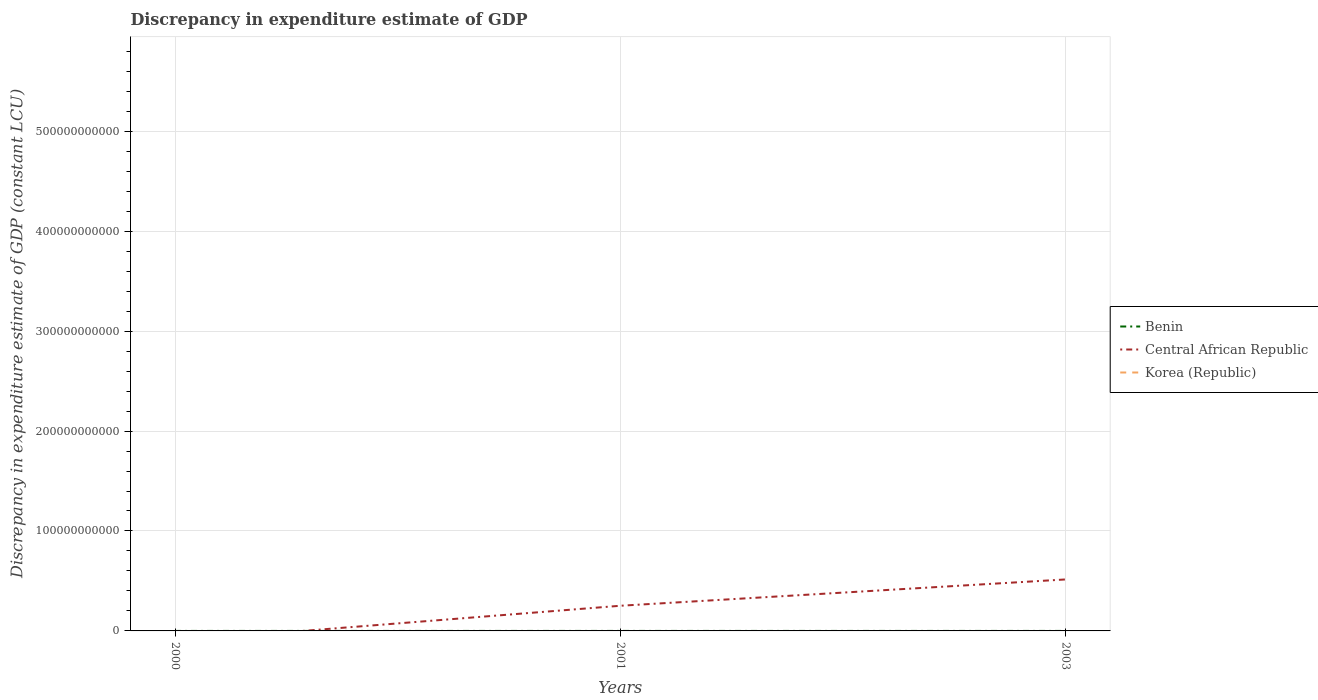Does the line corresponding to Korea (Republic) intersect with the line corresponding to Benin?
Ensure brevity in your answer.  No. Is the number of lines equal to the number of legend labels?
Ensure brevity in your answer.  No. What is the total discrepancy in expenditure estimate of GDP in Central African Republic in the graph?
Offer a very short reply. -2.63e+1. What is the difference between the highest and the lowest discrepancy in expenditure estimate of GDP in Central African Republic?
Your response must be concise. 1. How many lines are there?
Your answer should be compact. 2. What is the difference between two consecutive major ticks on the Y-axis?
Your answer should be compact. 1.00e+11. Are the values on the major ticks of Y-axis written in scientific E-notation?
Your response must be concise. No. Does the graph contain any zero values?
Your answer should be very brief. Yes. Does the graph contain grids?
Your response must be concise. Yes. Where does the legend appear in the graph?
Your answer should be very brief. Center right. How many legend labels are there?
Give a very brief answer. 3. What is the title of the graph?
Offer a very short reply. Discrepancy in expenditure estimate of GDP. Does "Brunei Darussalam" appear as one of the legend labels in the graph?
Ensure brevity in your answer.  No. What is the label or title of the Y-axis?
Provide a succinct answer. Discrepancy in expenditure estimate of GDP (constant LCU). What is the Discrepancy in expenditure estimate of GDP (constant LCU) of Benin in 2000?
Offer a terse response. 100. What is the Discrepancy in expenditure estimate of GDP (constant LCU) of Korea (Republic) in 2000?
Your answer should be compact. 0. What is the Discrepancy in expenditure estimate of GDP (constant LCU) of Central African Republic in 2001?
Your response must be concise. 2.52e+1. What is the Discrepancy in expenditure estimate of GDP (constant LCU) in Korea (Republic) in 2001?
Give a very brief answer. 0. What is the Discrepancy in expenditure estimate of GDP (constant LCU) in Benin in 2003?
Provide a succinct answer. 100. What is the Discrepancy in expenditure estimate of GDP (constant LCU) of Central African Republic in 2003?
Provide a succinct answer. 5.15e+1. Across all years, what is the maximum Discrepancy in expenditure estimate of GDP (constant LCU) in Benin?
Make the answer very short. 100. Across all years, what is the maximum Discrepancy in expenditure estimate of GDP (constant LCU) of Central African Republic?
Your response must be concise. 5.15e+1. What is the total Discrepancy in expenditure estimate of GDP (constant LCU) of Benin in the graph?
Ensure brevity in your answer.  300. What is the total Discrepancy in expenditure estimate of GDP (constant LCU) of Central African Republic in the graph?
Provide a succinct answer. 7.67e+1. What is the difference between the Discrepancy in expenditure estimate of GDP (constant LCU) in Benin in 2000 and that in 2001?
Make the answer very short. 0. What is the difference between the Discrepancy in expenditure estimate of GDP (constant LCU) of Benin in 2000 and that in 2003?
Ensure brevity in your answer.  0. What is the difference between the Discrepancy in expenditure estimate of GDP (constant LCU) of Central African Republic in 2001 and that in 2003?
Make the answer very short. -2.63e+1. What is the difference between the Discrepancy in expenditure estimate of GDP (constant LCU) in Benin in 2000 and the Discrepancy in expenditure estimate of GDP (constant LCU) in Central African Republic in 2001?
Offer a terse response. -2.52e+1. What is the difference between the Discrepancy in expenditure estimate of GDP (constant LCU) of Benin in 2000 and the Discrepancy in expenditure estimate of GDP (constant LCU) of Central African Republic in 2003?
Offer a terse response. -5.15e+1. What is the difference between the Discrepancy in expenditure estimate of GDP (constant LCU) in Benin in 2001 and the Discrepancy in expenditure estimate of GDP (constant LCU) in Central African Republic in 2003?
Offer a very short reply. -5.15e+1. What is the average Discrepancy in expenditure estimate of GDP (constant LCU) of Benin per year?
Give a very brief answer. 100. What is the average Discrepancy in expenditure estimate of GDP (constant LCU) in Central African Republic per year?
Your response must be concise. 2.56e+1. What is the average Discrepancy in expenditure estimate of GDP (constant LCU) of Korea (Republic) per year?
Provide a short and direct response. 0. In the year 2001, what is the difference between the Discrepancy in expenditure estimate of GDP (constant LCU) of Benin and Discrepancy in expenditure estimate of GDP (constant LCU) of Central African Republic?
Offer a very short reply. -2.52e+1. In the year 2003, what is the difference between the Discrepancy in expenditure estimate of GDP (constant LCU) of Benin and Discrepancy in expenditure estimate of GDP (constant LCU) of Central African Republic?
Offer a very short reply. -5.15e+1. What is the ratio of the Discrepancy in expenditure estimate of GDP (constant LCU) in Benin in 2000 to that in 2003?
Offer a very short reply. 1. What is the ratio of the Discrepancy in expenditure estimate of GDP (constant LCU) of Central African Republic in 2001 to that in 2003?
Offer a terse response. 0.49. What is the difference between the highest and the lowest Discrepancy in expenditure estimate of GDP (constant LCU) of Benin?
Provide a succinct answer. 0. What is the difference between the highest and the lowest Discrepancy in expenditure estimate of GDP (constant LCU) in Central African Republic?
Your response must be concise. 5.15e+1. 